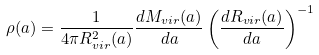<formula> <loc_0><loc_0><loc_500><loc_500>\rho ( a ) = \frac { 1 } { 4 \pi R ^ { 2 } _ { v i r } ( a ) } \frac { d M _ { v i r } ( a ) } { d a } \left ( \frac { d R _ { v i r } ( a ) } { d a } \right ) ^ { - 1 }</formula> 